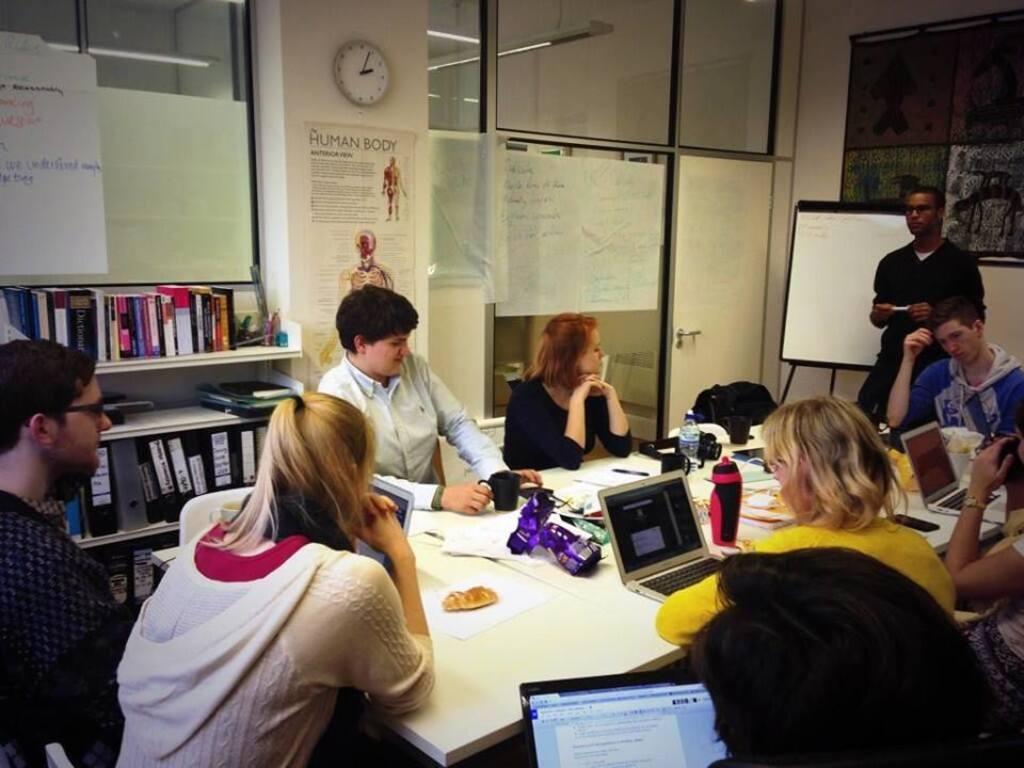In one or two sentences, can you explain what this image depicts? In this picture, we see many people sitting on the chairs around the table. Here, we see laptop, papers, cup, water bottle, plastic cover and mobile phone placed on that table. Behind them, we see a door and a wall on which posters and clock are placed. Beside that, we see a rack in which many books are placed. On the right corner of the picture, we see a white board with some text written on it. Beside that, the man in black jacket is holding a marker in his hand. Behind him, we see a black color board placed on the wall. 